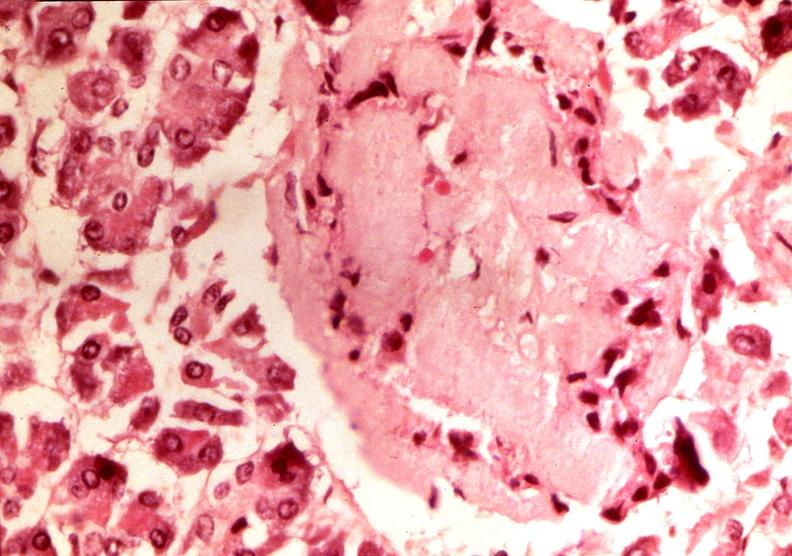what does this image show?
Answer the question using a single word or phrase. Pancrease 